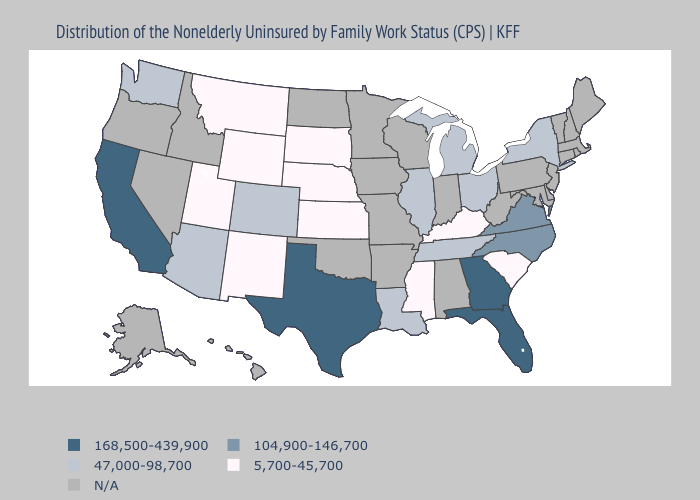What is the value of Iowa?
Write a very short answer. N/A. Among the states that border Ohio , which have the highest value?
Write a very short answer. Michigan. What is the value of Oklahoma?
Quick response, please. N/A. Does the map have missing data?
Give a very brief answer. Yes. Name the states that have a value in the range 47,000-98,700?
Answer briefly. Arizona, Colorado, Illinois, Louisiana, Michigan, New York, Ohio, Tennessee, Washington. Name the states that have a value in the range 104,900-146,700?
Quick response, please. North Carolina, Virginia. What is the value of Montana?
Short answer required. 5,700-45,700. How many symbols are there in the legend?
Write a very short answer. 5. Which states have the lowest value in the Northeast?
Answer briefly. New York. What is the highest value in the USA?
Short answer required. 168,500-439,900. 